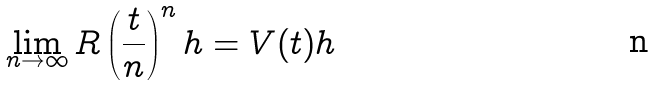Convert formula to latex. <formula><loc_0><loc_0><loc_500><loc_500>\lim _ { n \rightarrow \infty } R \left ( \frac { t } { n } \right ) ^ { n } h = V ( t ) h</formula> 